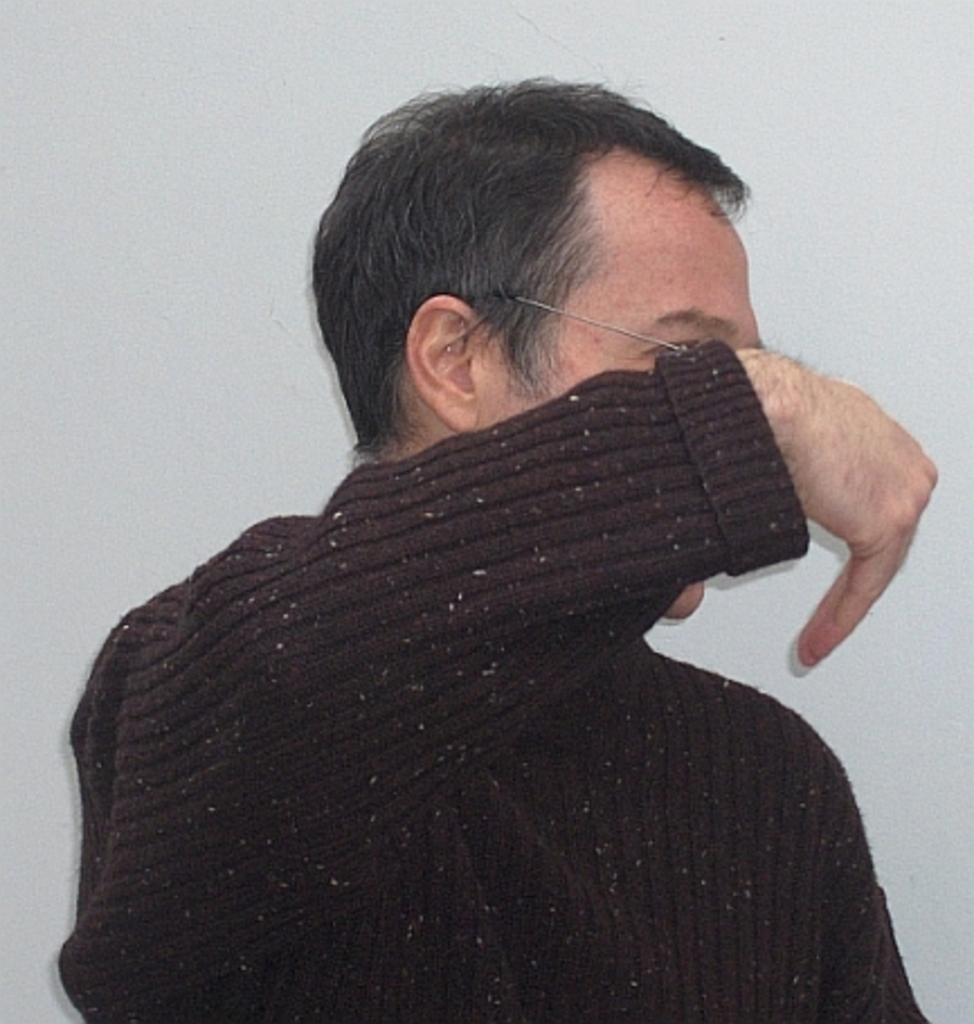Who or what is the main subject of the image? There is a person in the image. What is the person wearing? The person is wearing a woolen sweater. What color is the background of the image? The background of the image is white. How many lamps are visible in the image? There are no lamps visible in the image. What type of fruit is the person holding in the image? There is no fruit present in the image. 